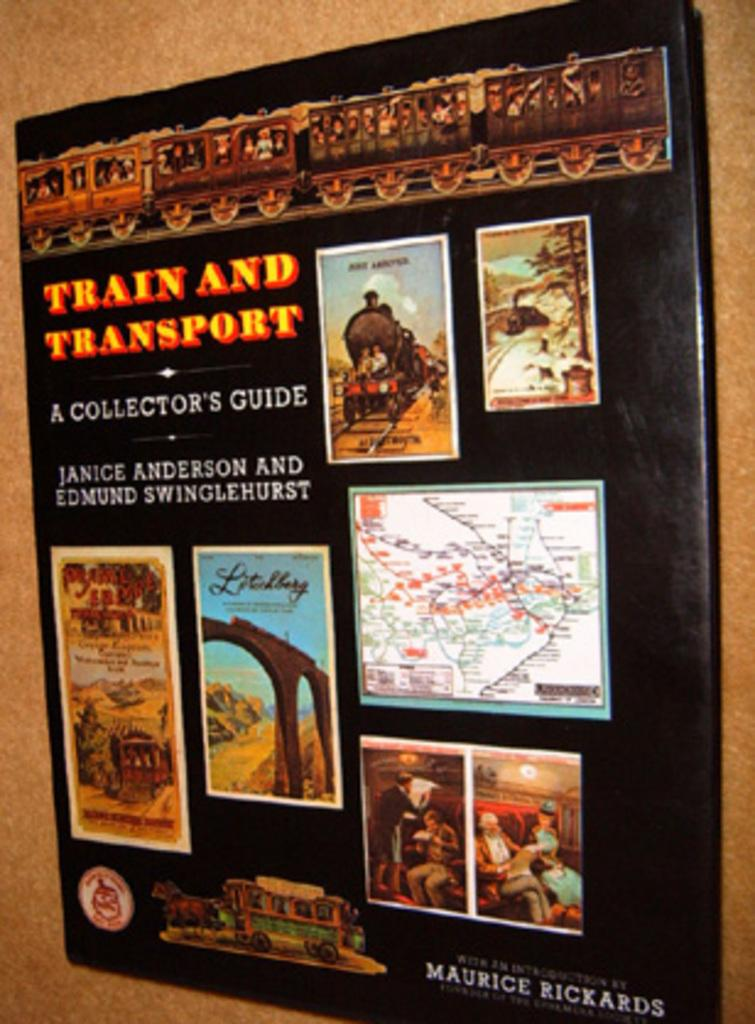<image>
Present a compact description of the photo's key features. A poster with a number of pictures and the words Train and Transport in orange. 